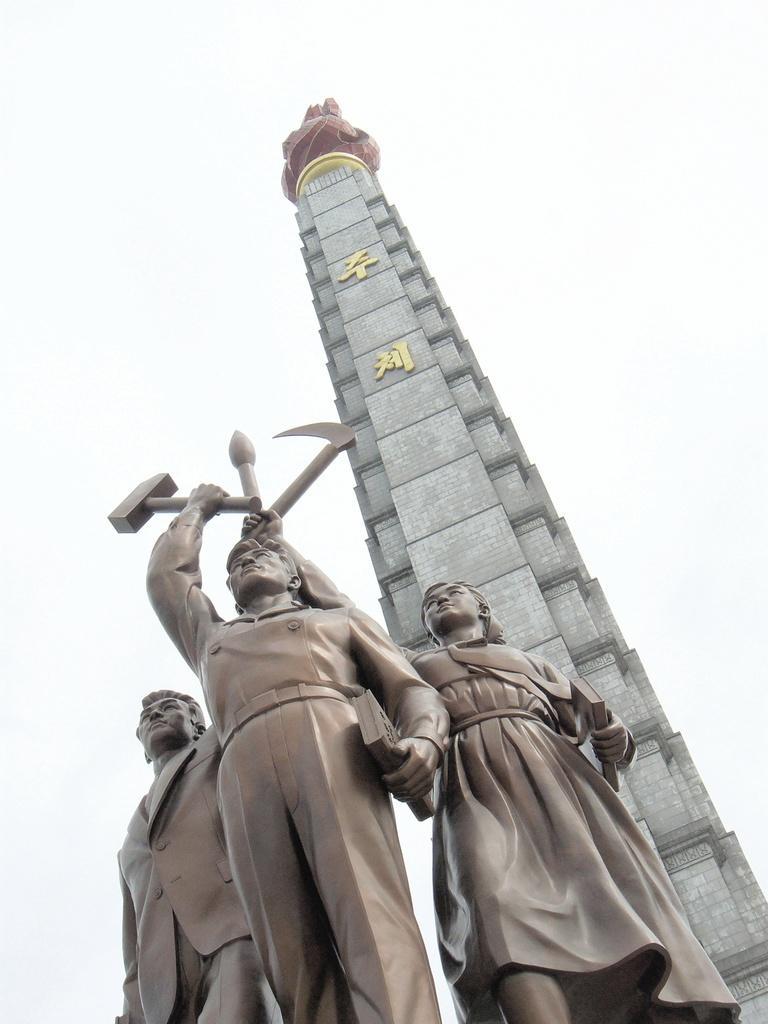How would you summarize this image in a sentence or two? In this image there is a sculpture of three people standing together and holding hammers, behind them there is a tower. 